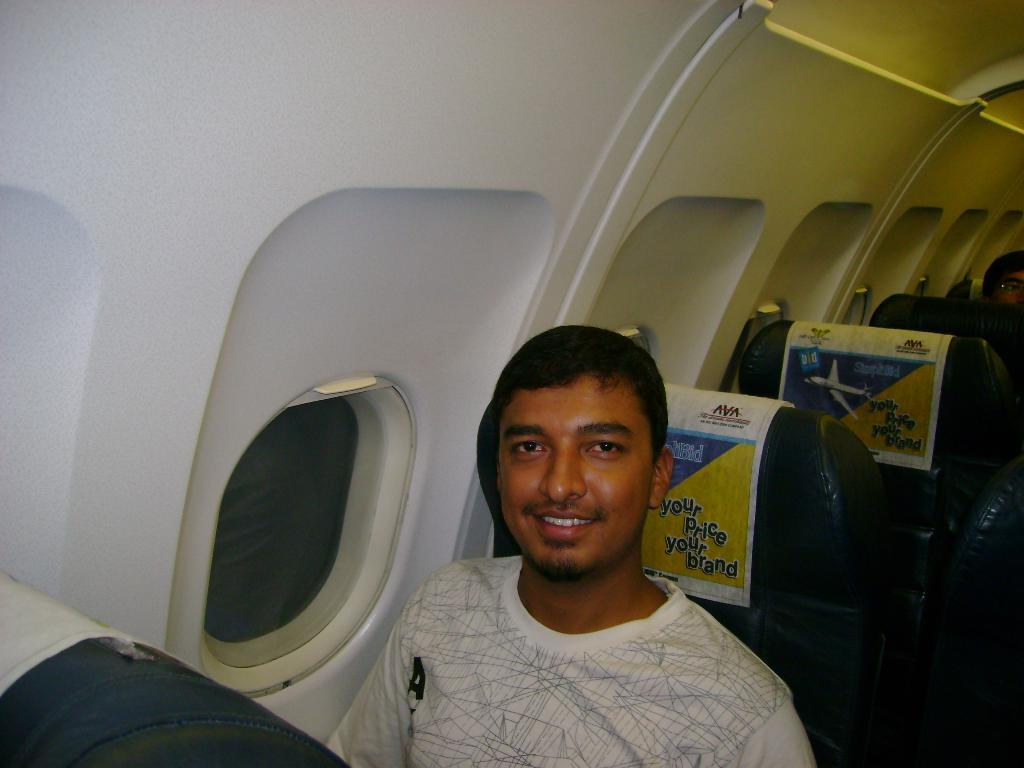Where was the image taken? The image was taken inside an airplane. What is the man in the image doing? The man is sitting on a seat. Can you describe the surroundings in the image? There are seats visible in the background. What type of hope can be seen in the image? There is no hope present in the image; it is a photograph taken inside an airplane. 